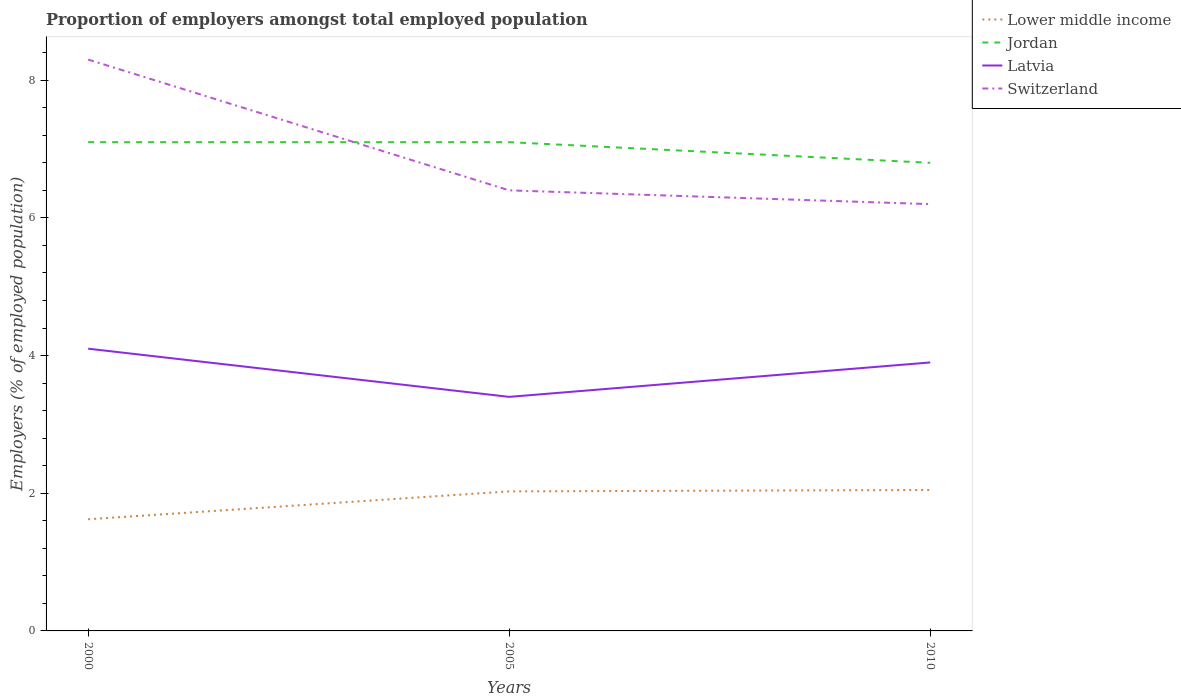Does the line corresponding to Latvia intersect with the line corresponding to Lower middle income?
Your answer should be compact. No. Across all years, what is the maximum proportion of employers in Switzerland?
Your response must be concise. 6.2. What is the total proportion of employers in Jordan in the graph?
Your answer should be very brief. 0. What is the difference between the highest and the second highest proportion of employers in Switzerland?
Your answer should be compact. 2.1. What is the difference between the highest and the lowest proportion of employers in Latvia?
Offer a terse response. 2. Are the values on the major ticks of Y-axis written in scientific E-notation?
Offer a very short reply. No. Does the graph contain any zero values?
Provide a succinct answer. No. Where does the legend appear in the graph?
Your answer should be compact. Top right. How are the legend labels stacked?
Keep it short and to the point. Vertical. What is the title of the graph?
Provide a short and direct response. Proportion of employers amongst total employed population. Does "New Caledonia" appear as one of the legend labels in the graph?
Your answer should be very brief. No. What is the label or title of the X-axis?
Offer a very short reply. Years. What is the label or title of the Y-axis?
Make the answer very short. Employers (% of employed population). What is the Employers (% of employed population) in Lower middle income in 2000?
Provide a short and direct response. 1.62. What is the Employers (% of employed population) in Jordan in 2000?
Keep it short and to the point. 7.1. What is the Employers (% of employed population) in Latvia in 2000?
Ensure brevity in your answer.  4.1. What is the Employers (% of employed population) in Switzerland in 2000?
Offer a terse response. 8.3. What is the Employers (% of employed population) of Lower middle income in 2005?
Provide a short and direct response. 2.03. What is the Employers (% of employed population) in Jordan in 2005?
Keep it short and to the point. 7.1. What is the Employers (% of employed population) in Latvia in 2005?
Offer a very short reply. 3.4. What is the Employers (% of employed population) of Switzerland in 2005?
Keep it short and to the point. 6.4. What is the Employers (% of employed population) of Lower middle income in 2010?
Your answer should be compact. 2.05. What is the Employers (% of employed population) in Jordan in 2010?
Provide a succinct answer. 6.8. What is the Employers (% of employed population) in Latvia in 2010?
Provide a succinct answer. 3.9. What is the Employers (% of employed population) in Switzerland in 2010?
Your answer should be very brief. 6.2. Across all years, what is the maximum Employers (% of employed population) in Lower middle income?
Give a very brief answer. 2.05. Across all years, what is the maximum Employers (% of employed population) of Jordan?
Keep it short and to the point. 7.1. Across all years, what is the maximum Employers (% of employed population) in Latvia?
Give a very brief answer. 4.1. Across all years, what is the maximum Employers (% of employed population) of Switzerland?
Give a very brief answer. 8.3. Across all years, what is the minimum Employers (% of employed population) of Lower middle income?
Your answer should be very brief. 1.62. Across all years, what is the minimum Employers (% of employed population) in Jordan?
Ensure brevity in your answer.  6.8. Across all years, what is the minimum Employers (% of employed population) of Latvia?
Provide a succinct answer. 3.4. Across all years, what is the minimum Employers (% of employed population) in Switzerland?
Provide a short and direct response. 6.2. What is the total Employers (% of employed population) in Lower middle income in the graph?
Offer a very short reply. 5.7. What is the total Employers (% of employed population) in Switzerland in the graph?
Your answer should be very brief. 20.9. What is the difference between the Employers (% of employed population) of Lower middle income in 2000 and that in 2005?
Keep it short and to the point. -0.4. What is the difference between the Employers (% of employed population) in Latvia in 2000 and that in 2005?
Give a very brief answer. 0.7. What is the difference between the Employers (% of employed population) in Switzerland in 2000 and that in 2005?
Provide a short and direct response. 1.9. What is the difference between the Employers (% of employed population) of Lower middle income in 2000 and that in 2010?
Your response must be concise. -0.43. What is the difference between the Employers (% of employed population) of Jordan in 2000 and that in 2010?
Your answer should be compact. 0.3. What is the difference between the Employers (% of employed population) of Switzerland in 2000 and that in 2010?
Give a very brief answer. 2.1. What is the difference between the Employers (% of employed population) in Lower middle income in 2005 and that in 2010?
Give a very brief answer. -0.02. What is the difference between the Employers (% of employed population) in Jordan in 2005 and that in 2010?
Your response must be concise. 0.3. What is the difference between the Employers (% of employed population) of Switzerland in 2005 and that in 2010?
Ensure brevity in your answer.  0.2. What is the difference between the Employers (% of employed population) in Lower middle income in 2000 and the Employers (% of employed population) in Jordan in 2005?
Give a very brief answer. -5.48. What is the difference between the Employers (% of employed population) in Lower middle income in 2000 and the Employers (% of employed population) in Latvia in 2005?
Offer a terse response. -1.78. What is the difference between the Employers (% of employed population) in Lower middle income in 2000 and the Employers (% of employed population) in Switzerland in 2005?
Provide a short and direct response. -4.78. What is the difference between the Employers (% of employed population) in Jordan in 2000 and the Employers (% of employed population) in Switzerland in 2005?
Your answer should be compact. 0.7. What is the difference between the Employers (% of employed population) of Latvia in 2000 and the Employers (% of employed population) of Switzerland in 2005?
Your answer should be compact. -2.3. What is the difference between the Employers (% of employed population) of Lower middle income in 2000 and the Employers (% of employed population) of Jordan in 2010?
Provide a succinct answer. -5.18. What is the difference between the Employers (% of employed population) of Lower middle income in 2000 and the Employers (% of employed population) of Latvia in 2010?
Provide a short and direct response. -2.28. What is the difference between the Employers (% of employed population) in Lower middle income in 2000 and the Employers (% of employed population) in Switzerland in 2010?
Provide a short and direct response. -4.58. What is the difference between the Employers (% of employed population) of Lower middle income in 2005 and the Employers (% of employed population) of Jordan in 2010?
Keep it short and to the point. -4.77. What is the difference between the Employers (% of employed population) in Lower middle income in 2005 and the Employers (% of employed population) in Latvia in 2010?
Your response must be concise. -1.87. What is the difference between the Employers (% of employed population) in Lower middle income in 2005 and the Employers (% of employed population) in Switzerland in 2010?
Your answer should be very brief. -4.17. What is the difference between the Employers (% of employed population) of Latvia in 2005 and the Employers (% of employed population) of Switzerland in 2010?
Your response must be concise. -2.8. What is the average Employers (% of employed population) of Lower middle income per year?
Make the answer very short. 1.9. What is the average Employers (% of employed population) of Jordan per year?
Make the answer very short. 7. What is the average Employers (% of employed population) of Latvia per year?
Offer a very short reply. 3.8. What is the average Employers (% of employed population) in Switzerland per year?
Your answer should be very brief. 6.97. In the year 2000, what is the difference between the Employers (% of employed population) in Lower middle income and Employers (% of employed population) in Jordan?
Offer a terse response. -5.48. In the year 2000, what is the difference between the Employers (% of employed population) of Lower middle income and Employers (% of employed population) of Latvia?
Provide a succinct answer. -2.48. In the year 2000, what is the difference between the Employers (% of employed population) of Lower middle income and Employers (% of employed population) of Switzerland?
Your answer should be compact. -6.68. In the year 2000, what is the difference between the Employers (% of employed population) in Latvia and Employers (% of employed population) in Switzerland?
Provide a short and direct response. -4.2. In the year 2005, what is the difference between the Employers (% of employed population) of Lower middle income and Employers (% of employed population) of Jordan?
Make the answer very short. -5.07. In the year 2005, what is the difference between the Employers (% of employed population) of Lower middle income and Employers (% of employed population) of Latvia?
Ensure brevity in your answer.  -1.37. In the year 2005, what is the difference between the Employers (% of employed population) of Lower middle income and Employers (% of employed population) of Switzerland?
Your response must be concise. -4.37. In the year 2005, what is the difference between the Employers (% of employed population) of Jordan and Employers (% of employed population) of Latvia?
Ensure brevity in your answer.  3.7. In the year 2005, what is the difference between the Employers (% of employed population) in Jordan and Employers (% of employed population) in Switzerland?
Your response must be concise. 0.7. In the year 2005, what is the difference between the Employers (% of employed population) of Latvia and Employers (% of employed population) of Switzerland?
Your response must be concise. -3. In the year 2010, what is the difference between the Employers (% of employed population) in Lower middle income and Employers (% of employed population) in Jordan?
Your response must be concise. -4.75. In the year 2010, what is the difference between the Employers (% of employed population) in Lower middle income and Employers (% of employed population) in Latvia?
Your response must be concise. -1.85. In the year 2010, what is the difference between the Employers (% of employed population) of Lower middle income and Employers (% of employed population) of Switzerland?
Offer a very short reply. -4.15. In the year 2010, what is the difference between the Employers (% of employed population) in Jordan and Employers (% of employed population) in Latvia?
Your answer should be compact. 2.9. What is the ratio of the Employers (% of employed population) of Lower middle income in 2000 to that in 2005?
Make the answer very short. 0.8. What is the ratio of the Employers (% of employed population) in Jordan in 2000 to that in 2005?
Give a very brief answer. 1. What is the ratio of the Employers (% of employed population) of Latvia in 2000 to that in 2005?
Keep it short and to the point. 1.21. What is the ratio of the Employers (% of employed population) in Switzerland in 2000 to that in 2005?
Ensure brevity in your answer.  1.3. What is the ratio of the Employers (% of employed population) of Lower middle income in 2000 to that in 2010?
Ensure brevity in your answer.  0.79. What is the ratio of the Employers (% of employed population) in Jordan in 2000 to that in 2010?
Provide a succinct answer. 1.04. What is the ratio of the Employers (% of employed population) in Latvia in 2000 to that in 2010?
Make the answer very short. 1.05. What is the ratio of the Employers (% of employed population) in Switzerland in 2000 to that in 2010?
Ensure brevity in your answer.  1.34. What is the ratio of the Employers (% of employed population) in Jordan in 2005 to that in 2010?
Provide a succinct answer. 1.04. What is the ratio of the Employers (% of employed population) in Latvia in 2005 to that in 2010?
Provide a short and direct response. 0.87. What is the ratio of the Employers (% of employed population) of Switzerland in 2005 to that in 2010?
Offer a very short reply. 1.03. What is the difference between the highest and the second highest Employers (% of employed population) of Lower middle income?
Offer a very short reply. 0.02. What is the difference between the highest and the second highest Employers (% of employed population) in Switzerland?
Offer a very short reply. 1.9. What is the difference between the highest and the lowest Employers (% of employed population) in Lower middle income?
Your answer should be very brief. 0.43. What is the difference between the highest and the lowest Employers (% of employed population) in Jordan?
Provide a succinct answer. 0.3. What is the difference between the highest and the lowest Employers (% of employed population) of Latvia?
Ensure brevity in your answer.  0.7. What is the difference between the highest and the lowest Employers (% of employed population) in Switzerland?
Make the answer very short. 2.1. 